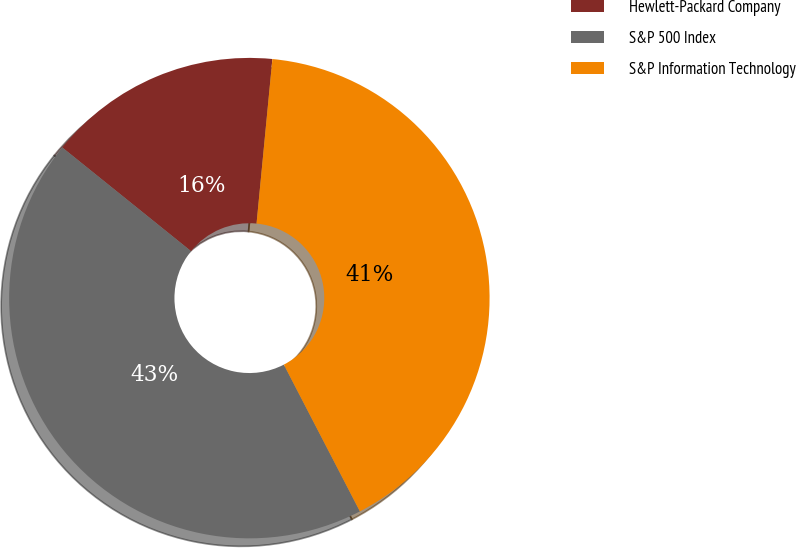<chart> <loc_0><loc_0><loc_500><loc_500><pie_chart><fcel>Hewlett-Packard Company<fcel>S&P 500 Index<fcel>S&P Information Technology<nl><fcel>15.74%<fcel>43.4%<fcel>40.86%<nl></chart> 